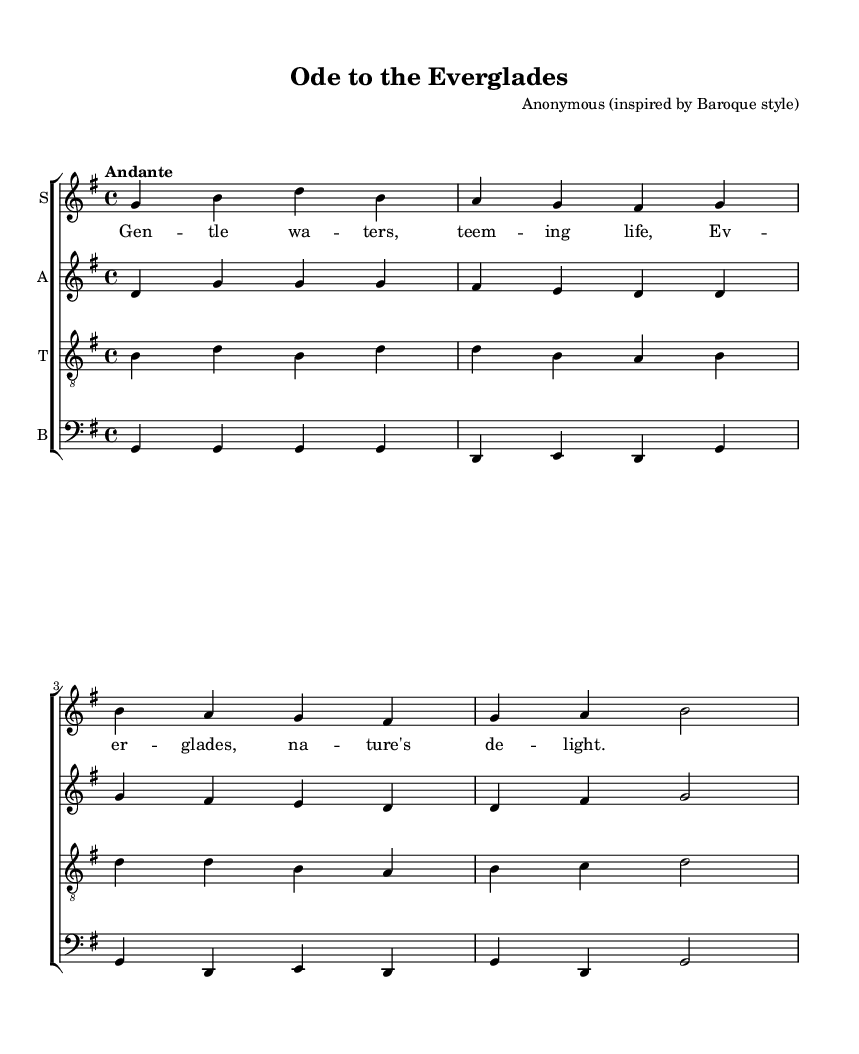What is the key signature of this music? The key signature is G major, which features one sharp (F#). This can be identified by looking at the symbols located at the beginning of the staff.
Answer: G major What is the time signature of the piece? The time signature is 4/4, as indicated by the numbers at the beginning of the music staff. This means there are four beats in each measure, and a quarter note receives one beat.
Answer: 4/4 What is the tempo marking for this piece? The tempo marking is "Andante," which suggests a moderate walking pace in the speed of the music. This is noted in the tempo directive placed above the staff.
Answer: Andante How many musical parts are written in this score? There are four musical parts: soprano, alto, tenor, and bass. This can be confirmed by observing the four staves labeled with their respective vocal parts.
Answer: Four What are the opening lyrics of the piece? The opening lyrics are "Gentle waters, teeming life," which can be seen aligned with the soprano staff under the lyrics section.
Answer: Gentle waters, teeming life Which vocal part has the highest pitch? The soprano part has the highest pitch, as indicated by its position on the staff and the range of notes it typically sings compared to the other parts.
Answer: Soprano What is the last note of the bass part? The last note of the bass part is G, which is at the end of the final measure. This can be determined by analyzing the final notes written in the bass staff.
Answer: G 